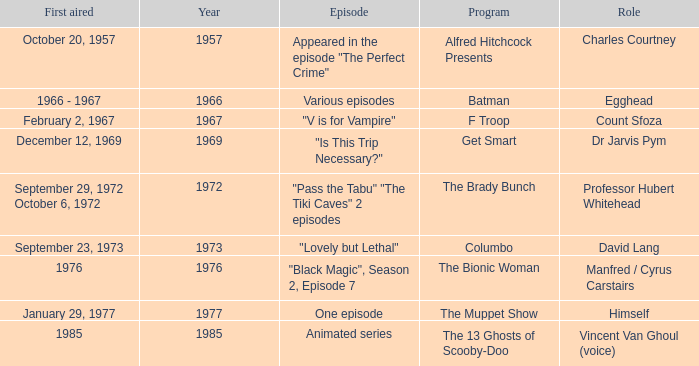What's the first aired date of the Animated Series episode? 1985.0. 